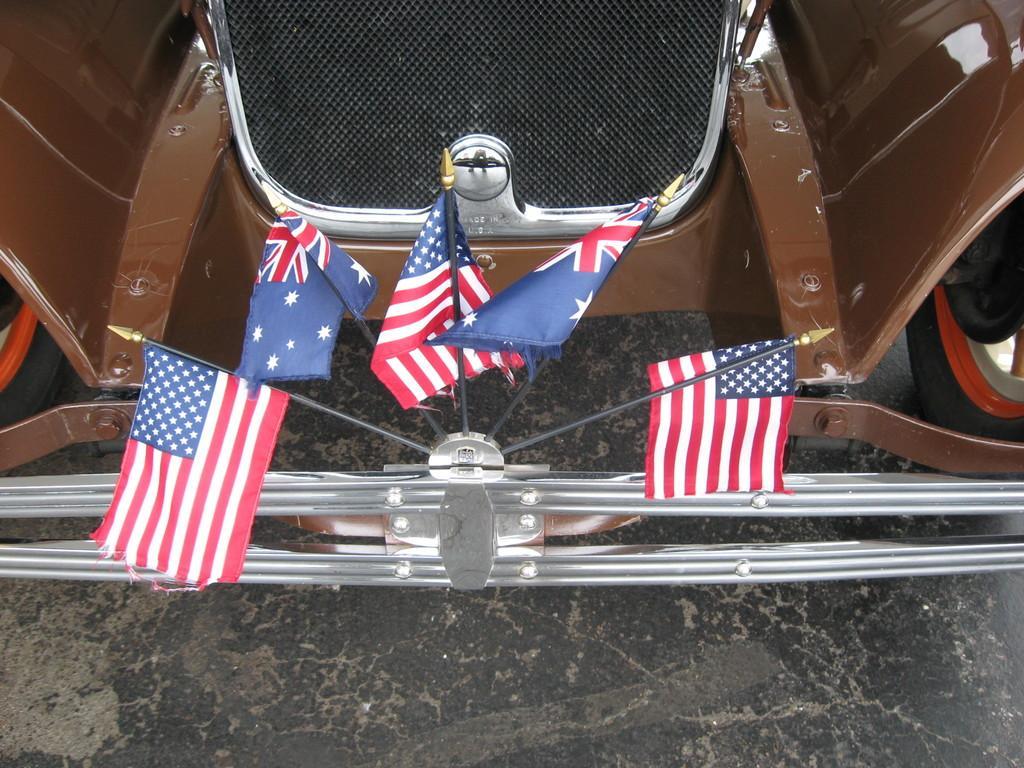Could you give a brief overview of what you see in this image? In this picture we can see few flags and a car. 